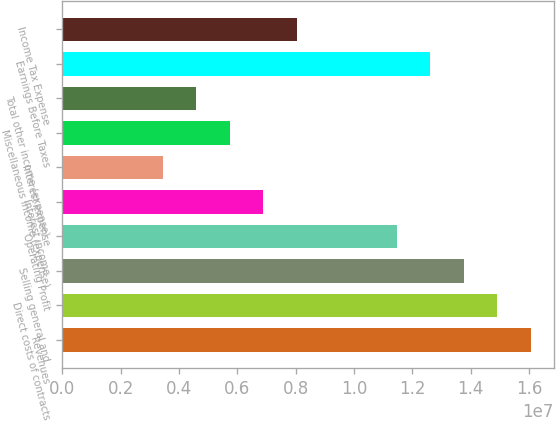<chart> <loc_0><loc_0><loc_500><loc_500><bar_chart><fcel>Revenues<fcel>Direct costs of contracts<fcel>Selling general and<fcel>Operating Profit<fcel>Interest income<fcel>Interest expense<fcel>Miscellaneous income (expense)<fcel>Total other income (expense)<fcel>Earnings Before Taxes<fcel>Income Tax Expense<nl><fcel>1.60543e+07<fcel>1.49076e+07<fcel>1.37609e+07<fcel>1.14674e+07<fcel>6.88043e+06<fcel>3.44022e+06<fcel>5.73369e+06<fcel>4.58695e+06<fcel>1.26141e+07<fcel>8.02716e+06<nl></chart> 